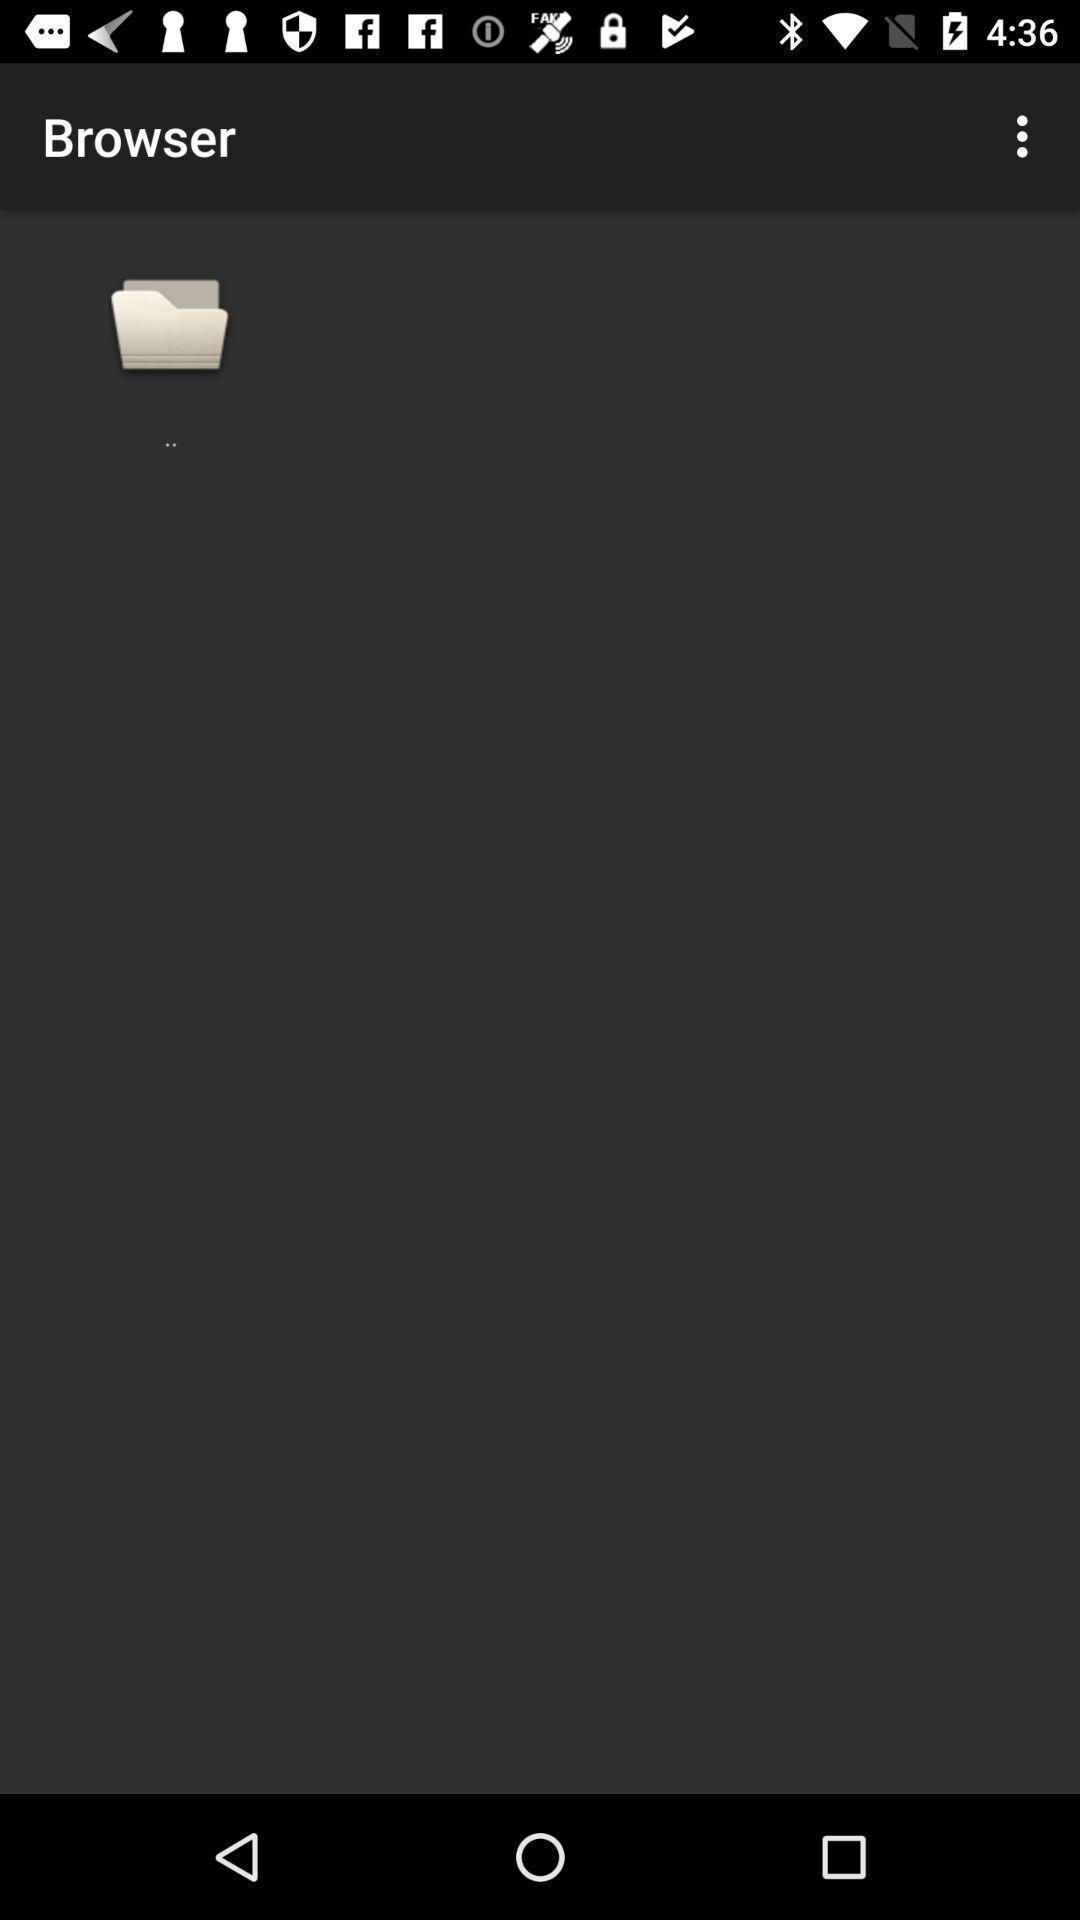Provide a description of this screenshot. Screen displaying folder contents in browser page. 